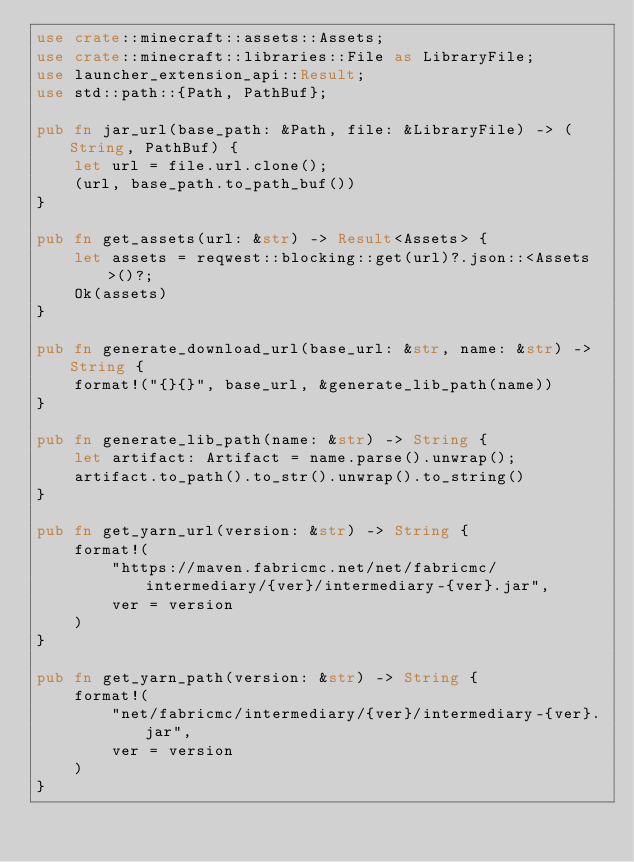<code> <loc_0><loc_0><loc_500><loc_500><_Rust_>use crate::minecraft::assets::Assets;
use crate::minecraft::libraries::File as LibraryFile;
use launcher_extension_api::Result;
use std::path::{Path, PathBuf};

pub fn jar_url(base_path: &Path, file: &LibraryFile) -> (String, PathBuf) {
    let url = file.url.clone();
    (url, base_path.to_path_buf())
}

pub fn get_assets(url: &str) -> Result<Assets> {
    let assets = reqwest::blocking::get(url)?.json::<Assets>()?;
    Ok(assets)
}

pub fn generate_download_url(base_url: &str, name: &str) -> String {
    format!("{}{}", base_url, &generate_lib_path(name))
}

pub fn generate_lib_path(name: &str) -> String {
    let artifact: Artifact = name.parse().unwrap();
    artifact.to_path().to_str().unwrap().to_string()
}

pub fn get_yarn_url(version: &str) -> String {
    format!(
        "https://maven.fabricmc.net/net/fabricmc/intermediary/{ver}/intermediary-{ver}.jar",
        ver = version
    )
}

pub fn get_yarn_path(version: &str) -> String {
    format!(
        "net/fabricmc/intermediary/{ver}/intermediary-{ver}.jar",
        ver = version
    )
}
</code> 